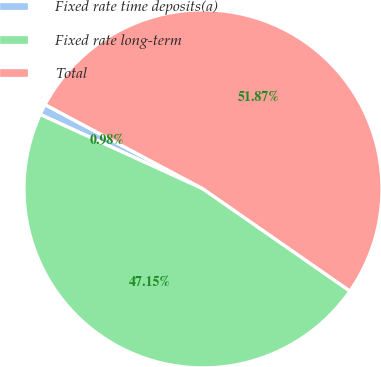Convert chart to OTSL. <chart><loc_0><loc_0><loc_500><loc_500><pie_chart><fcel>Fixed rate time deposits(a)<fcel>Fixed rate long-term<fcel>Total<nl><fcel>0.98%<fcel>47.15%<fcel>51.87%<nl></chart> 